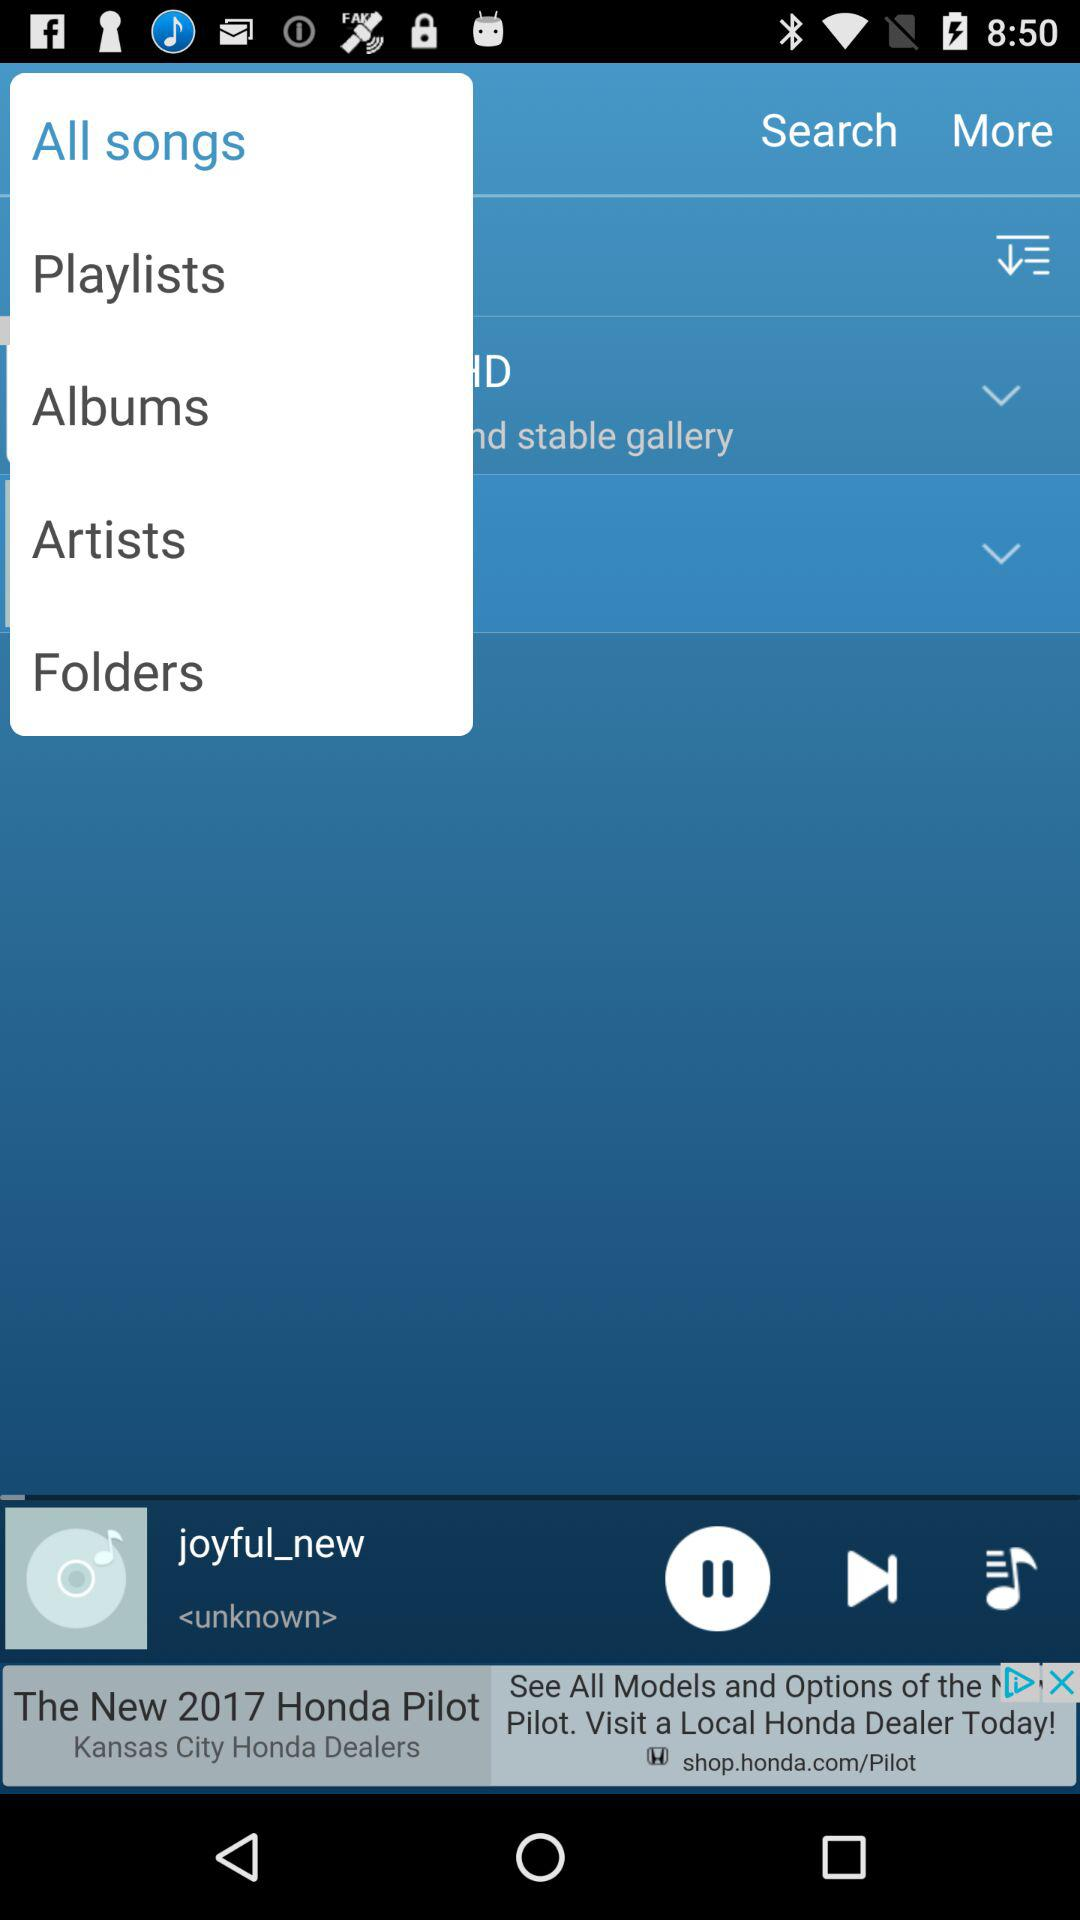Which song is playing? The song playing is "joyful_new". 